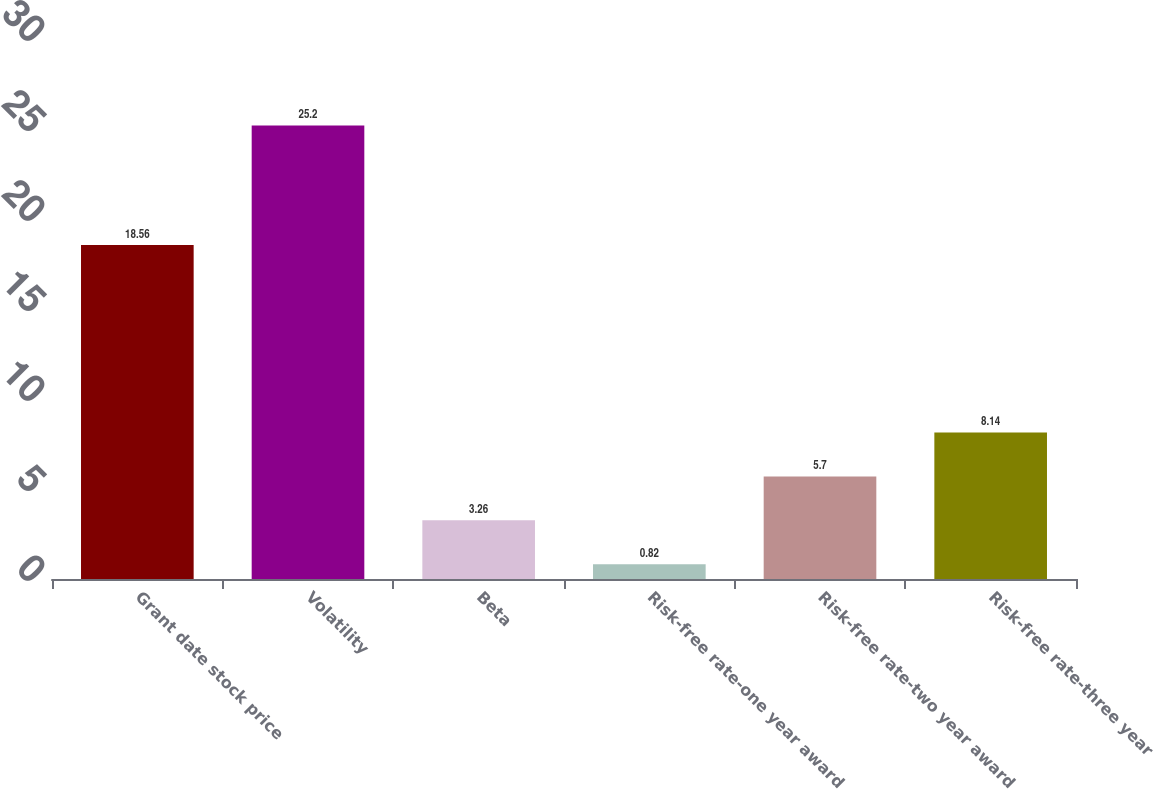Convert chart to OTSL. <chart><loc_0><loc_0><loc_500><loc_500><bar_chart><fcel>Grant date stock price<fcel>Volatility<fcel>Beta<fcel>Risk-free rate-one year award<fcel>Risk-free rate-two year award<fcel>Risk-free rate-three year<nl><fcel>18.56<fcel>25.2<fcel>3.26<fcel>0.82<fcel>5.7<fcel>8.14<nl></chart> 